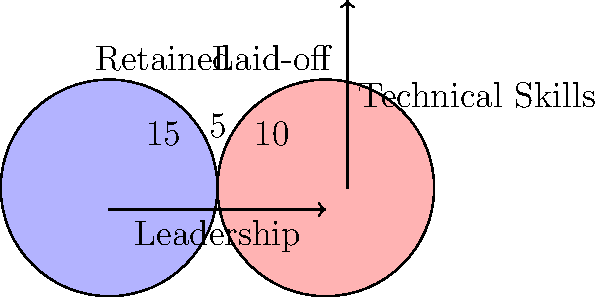Based on the Venn diagram showing the skill sets of retained and laid-off workers after a corporate takeover, what percentage of workers with both leadership and technical skills were retained? To solve this problem, let's follow these steps:

1. Identify the total number of workers with both leadership and technical skills:
   - This is represented by the overlapping area of the two circles, which shows 5 workers.

2. Determine the number of workers with both skills who were retained:
   - The left circle represents retained workers.
   - The overlapping area is entirely within the "Retained" circle.
   - Therefore, all 5 workers with both skills were retained.

3. Calculate the percentage:
   - Total workers with both skills: 5
   - Retained workers with both skills: 5
   - Percentage calculation: $\frac{5}{5} \times 100\% = 100\%$

Thus, 100% of workers with both leadership and technical skills were retained during the corporate takeover.
Answer: 100% 